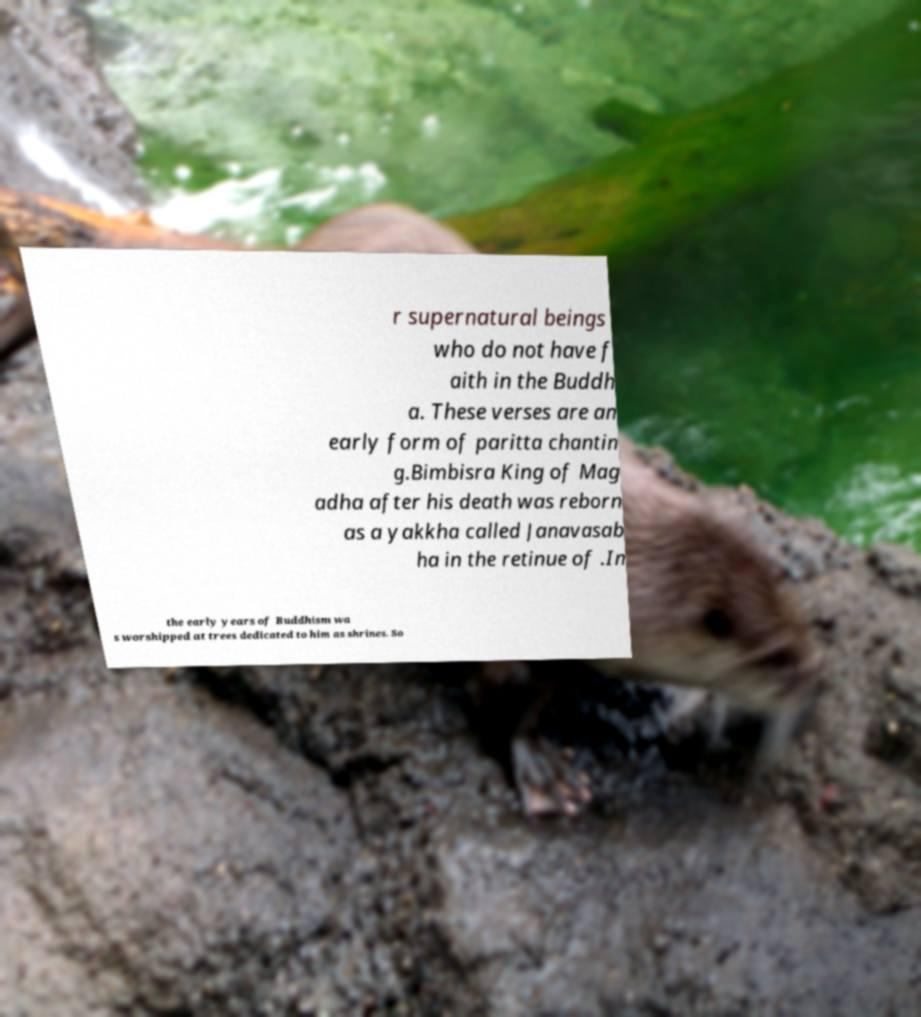Can you read and provide the text displayed in the image?This photo seems to have some interesting text. Can you extract and type it out for me? r supernatural beings who do not have f aith in the Buddh a. These verses are an early form of paritta chantin g.Bimbisra King of Mag adha after his death was reborn as a yakkha called Janavasab ha in the retinue of .In the early years of Buddhism wa s worshipped at trees dedicated to him as shrines. So 